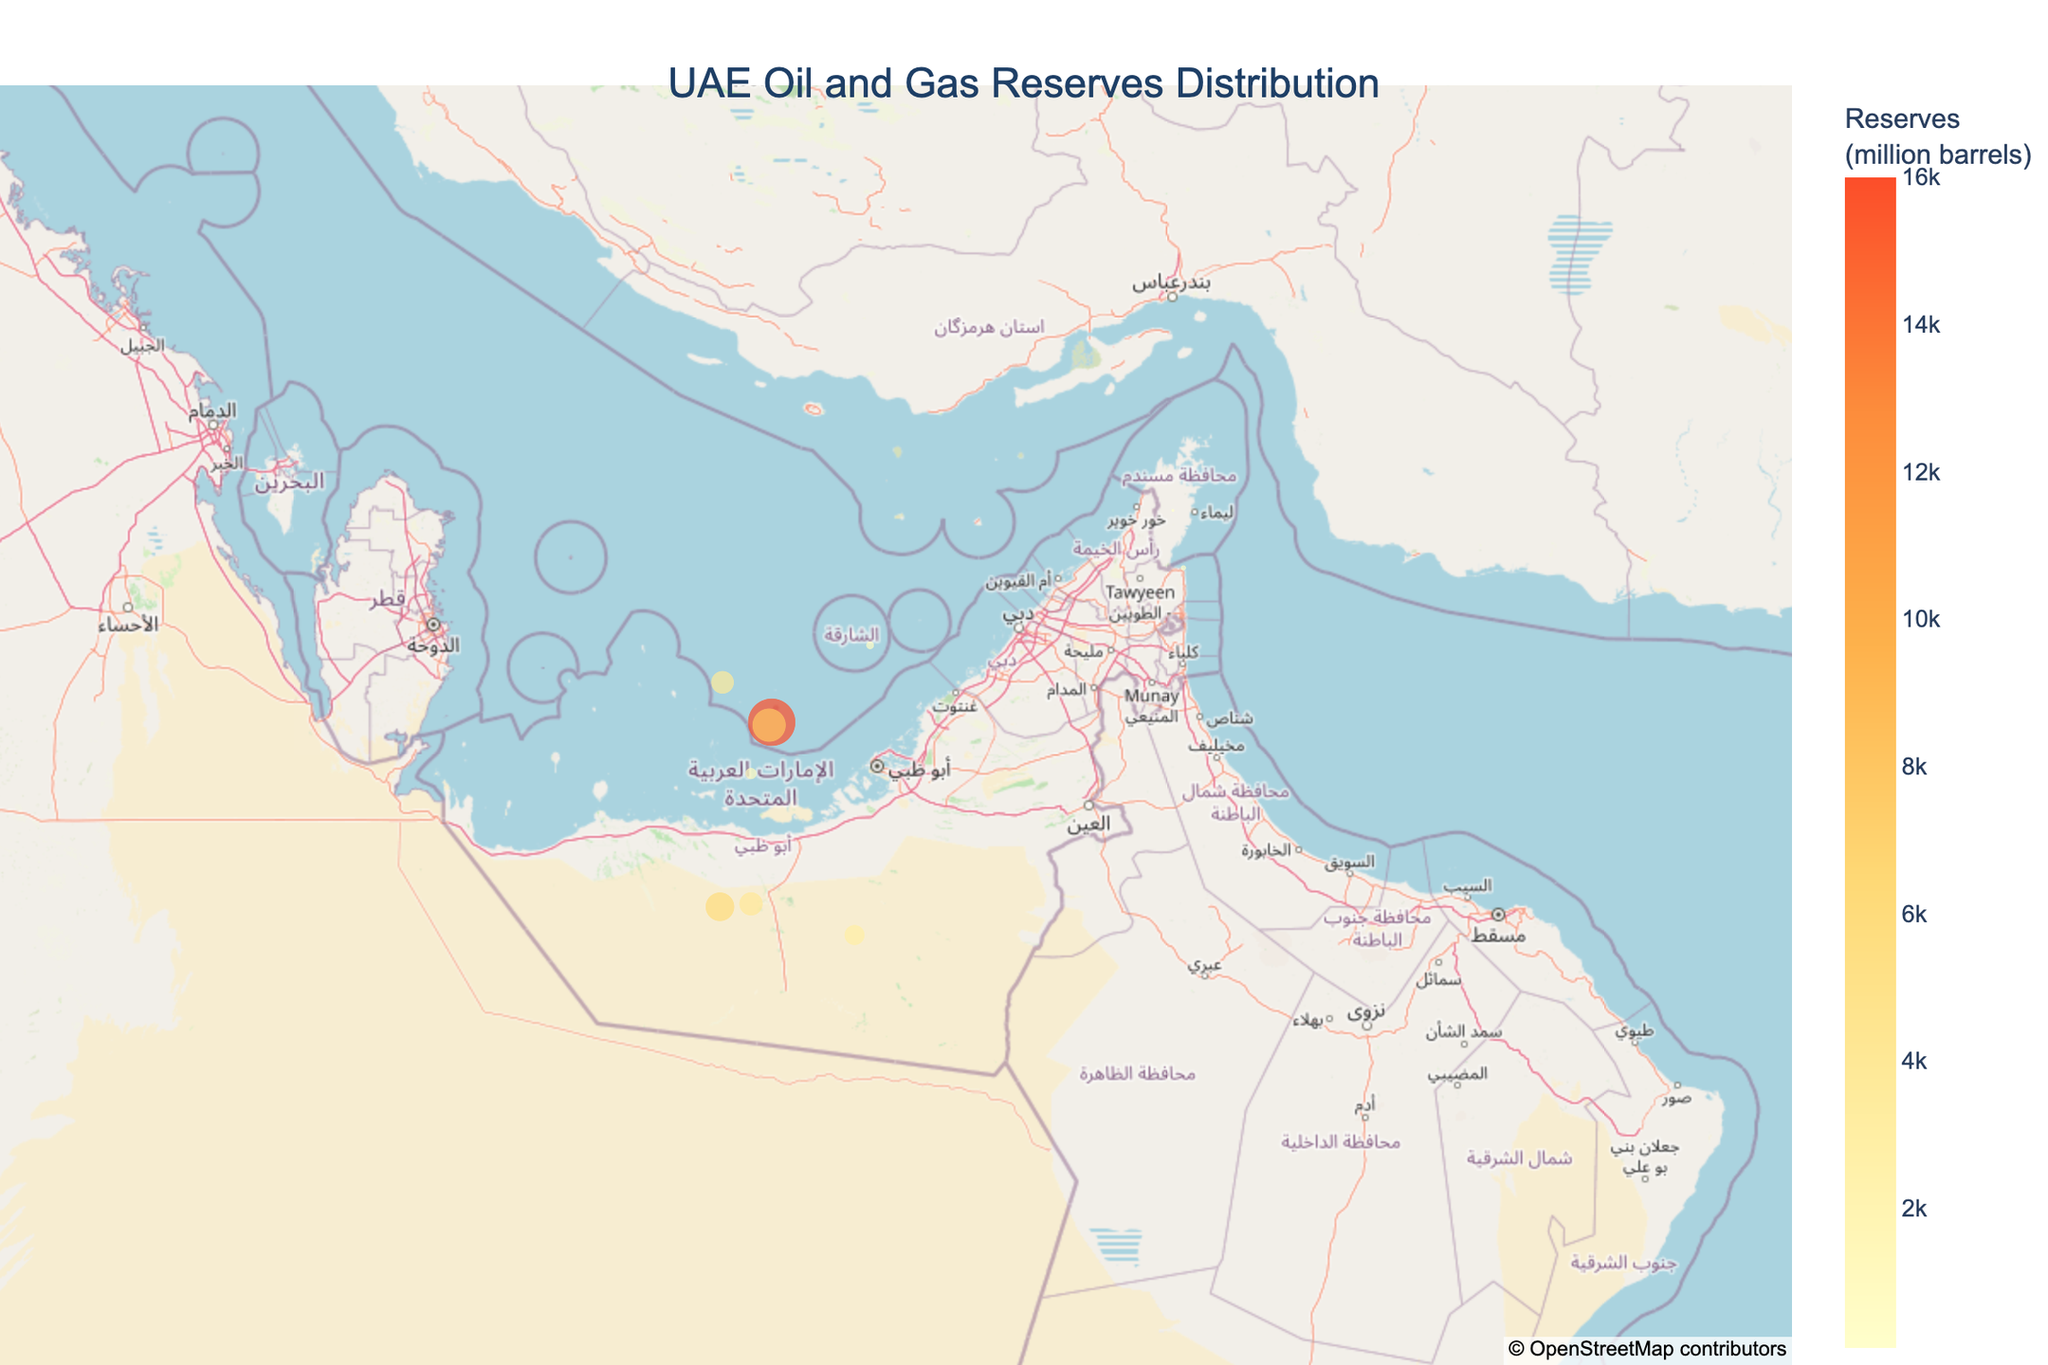What's the title of the figure? The title of the figure is usually displayed at the top center of the plot. The title in this case reads "UAE Oil and Gas Reserves Distribution".
Answer: UAE Oil and Gas Reserves Distribution Which Emirate has the field with the highest reserves? By looking at the size of the circles and the reserve values, we can identify the largest circle representing the Upper Zakum field in Abu Dhabi, which has 16,000 million barrels.
Answer: Abu Dhabi What is the geolocation (Latitude and Longitude) of the Mubarak field? The hover information for the Mubarak field shows its geographic coordinates as latitude 25.6167 and longitude 56.3500.
Answer: Latitude: 25.6167, Longitude: 56.3500 How many offshore fields are shown in the plot? Counting the number of fields identified as "Offshore" in their hover information, we find there are a total of 7 offshore fields.
Answer: 7 What is the total oil reserves for the Emirate of Abu Dhabi? Summing the reserves for all fields in Abu Dhabi (Upper Zakum: 16000, Lower Zakum: 8000, Umm Shaif: 3800, Satah: 1000, Bu Hasa: 6000, Bab: 4000, Asab: 3000): 16000 + 8000 + 3800 + 1000 + 6000 + 4000 + 3000 = 38800
Answer: 38800 million barrels Between the Fateh field in Dubai and the Saleh field in Ras Al Khaimah, which one has higher reserves and by how much? From the hover data, the Fateh field has 500 million barrels, and Saleh has 100 million barrels. The difference is 500 - 100 = 400 million barrels.
Answer: Fateh by 400 million barrels What is the average reserve of the onshore fields in Abu Dhabi? The onshore fields in Abu Dhabi are Bu Hasa: 6000, Bab: 4000, Asab: 3000). The sum is 6000 + 4000 + 3000 = 13000. The average is 13000 / 3 ≈ 4333.33 million barrels.
Answer: 4333.33 million barrels Which field has the smallest reserves, and which Emirate does it belong to? The smallest circle on the map represents the Saleh field in Ras Al Khaimah with 100 million barrels.
Answer: Saleh, Ras Al Khaimah 